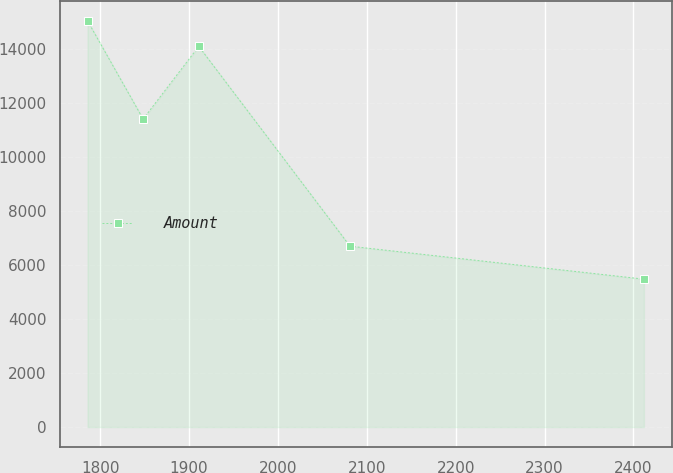<chart> <loc_0><loc_0><loc_500><loc_500><line_chart><ecel><fcel>Amount<nl><fcel>1785.83<fcel>15058.3<nl><fcel>1848.42<fcel>11417.9<nl><fcel>1911.01<fcel>14112.5<nl><fcel>2081.13<fcel>6704.07<nl><fcel>2411.77<fcel>5482.8<nl></chart> 